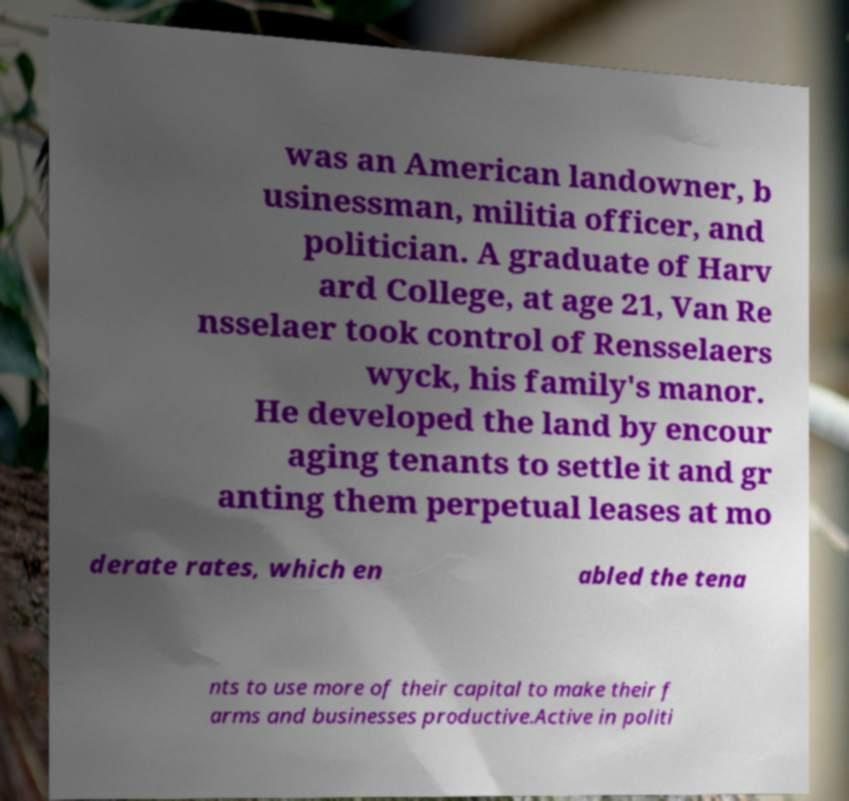Could you extract and type out the text from this image? was an American landowner, b usinessman, militia officer, and politician. A graduate of Harv ard College, at age 21, Van Re nsselaer took control of Rensselaers wyck, his family's manor. He developed the land by encour aging tenants to settle it and gr anting them perpetual leases at mo derate rates, which en abled the tena nts to use more of their capital to make their f arms and businesses productive.Active in politi 